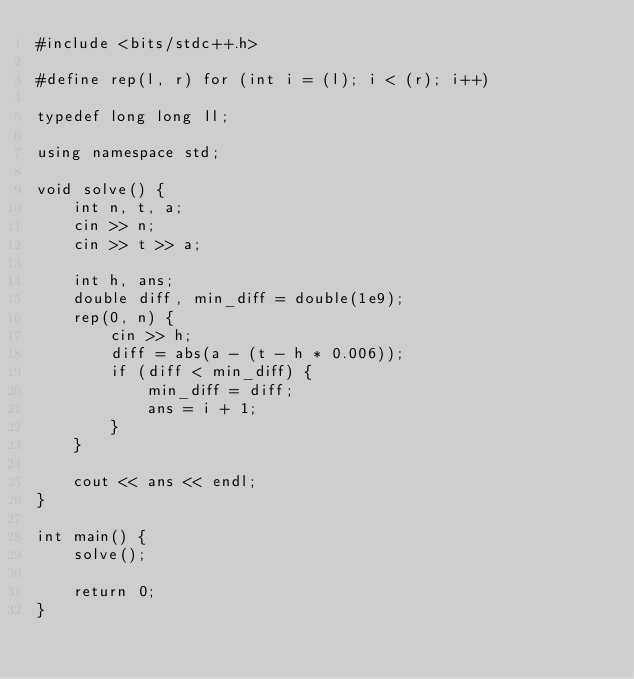Convert code to text. <code><loc_0><loc_0><loc_500><loc_500><_C++_>#include <bits/stdc++.h>

#define rep(l, r) for (int i = (l); i < (r); i++)

typedef long long ll;
 
using namespace std;

void solve() {
    int n, t, a;
    cin >> n;
    cin >> t >> a;

    int h, ans;
    double diff, min_diff = double(1e9);
    rep(0, n) {
        cin >> h;
        diff = abs(a - (t - h * 0.006));
        if (diff < min_diff) {
            min_diff = diff;
            ans = i + 1;
        }
    }

    cout << ans << endl;
}

int main() {
    solve();

    return 0;
}
</code> 